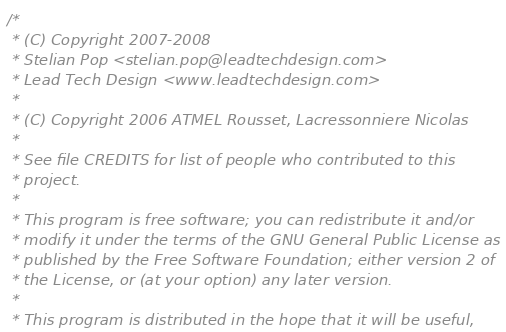Convert code to text. <code><loc_0><loc_0><loc_500><loc_500><_C_>/*
 * (C) Copyright 2007-2008
 * Stelian Pop <stelian.pop@leadtechdesign.com>
 * Lead Tech Design <www.leadtechdesign.com>
 *
 * (C) Copyright 2006 ATMEL Rousset, Lacressonniere Nicolas
 *
 * See file CREDITS for list of people who contributed to this
 * project.
 *
 * This program is free software; you can redistribute it and/or
 * modify it under the terms of the GNU General Public License as
 * published by the Free Software Foundation; either version 2 of
 * the License, or (at your option) any later version.
 *
 * This program is distributed in the hope that it will be useful,</code> 